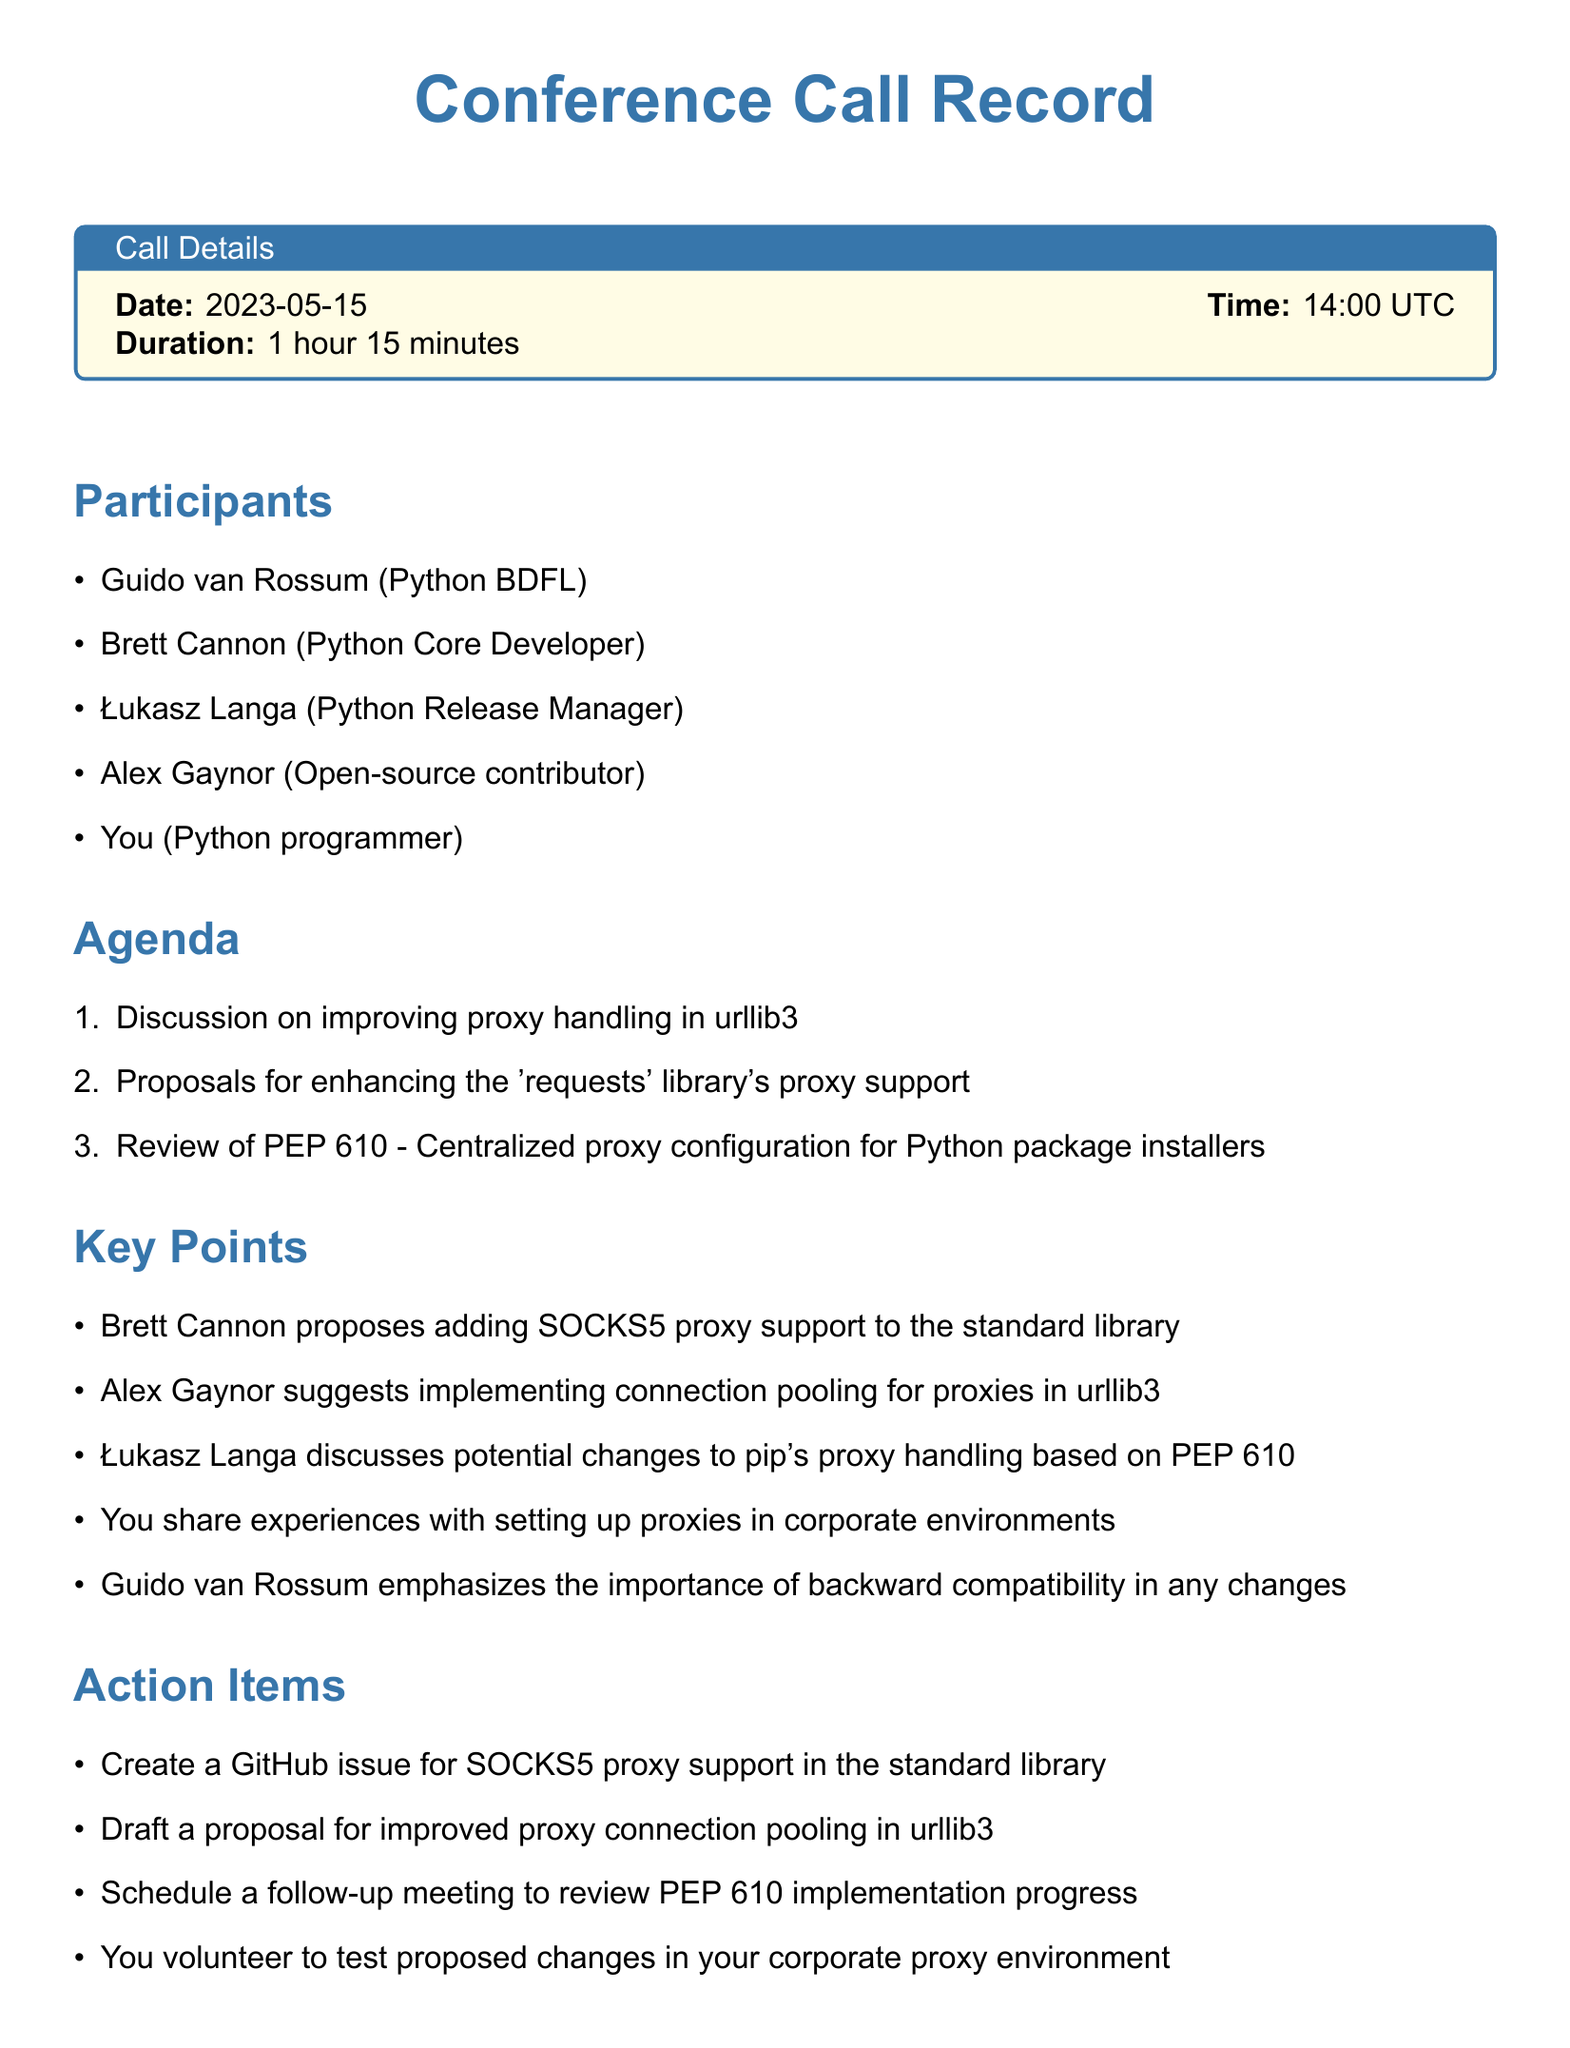What date was the conference call held? The date of the conference call is specified in the call details section of the document.
Answer: 2023-05-15 Who proposed adding SOCKS5 proxy support? Brett Cannon is the participant who proposed adding SOCKS5 proxy support, as mentioned in the key points section.
Answer: Brett Cannon What is one of the action items from the call? Various action items are listed in the action items section, and one example can be extracted from there.
Answer: Create a GitHub issue for SOCKS5 proxy support in the standard library What is the duration of the conference call? The duration of the call is given in the call details section, specifying the total time spent.
Answer: 1 hour 15 minutes When is the follow-up meeting scheduled? The next steps section contains the scheduled date for the follow-up meeting.
Answer: 2023-06-01 What proposal did Alex Gaynor suggest? The proposal made by Alex Gaynor is mentioned in the key points section regarding urllib3.
Answer: Implementing connection pooling for proxies in urllib3 What is the agenda item related to PEP 610? The agenda mentions reviewing PEP 610 and its relation to proxy handling, which requires identifying specific actions or proposals regarding it.
Answer: Review of PEP 610 - Centralized proxy configuration for Python package installers Why did Guido van Rossum emphasize backward compatibility? The importance of backward compatibility is discussed in the key points, reflecting Guido van Rossum's concern for existing users.
Answer: Importance of backward compatibility What is scheduled for ongoing proxy-related discussions? The next steps section denotes plans for creating a communication channel for discussions about proxy handling.
Answer: Create a dedicated Slack channel for ongoing proxy-related discussions 